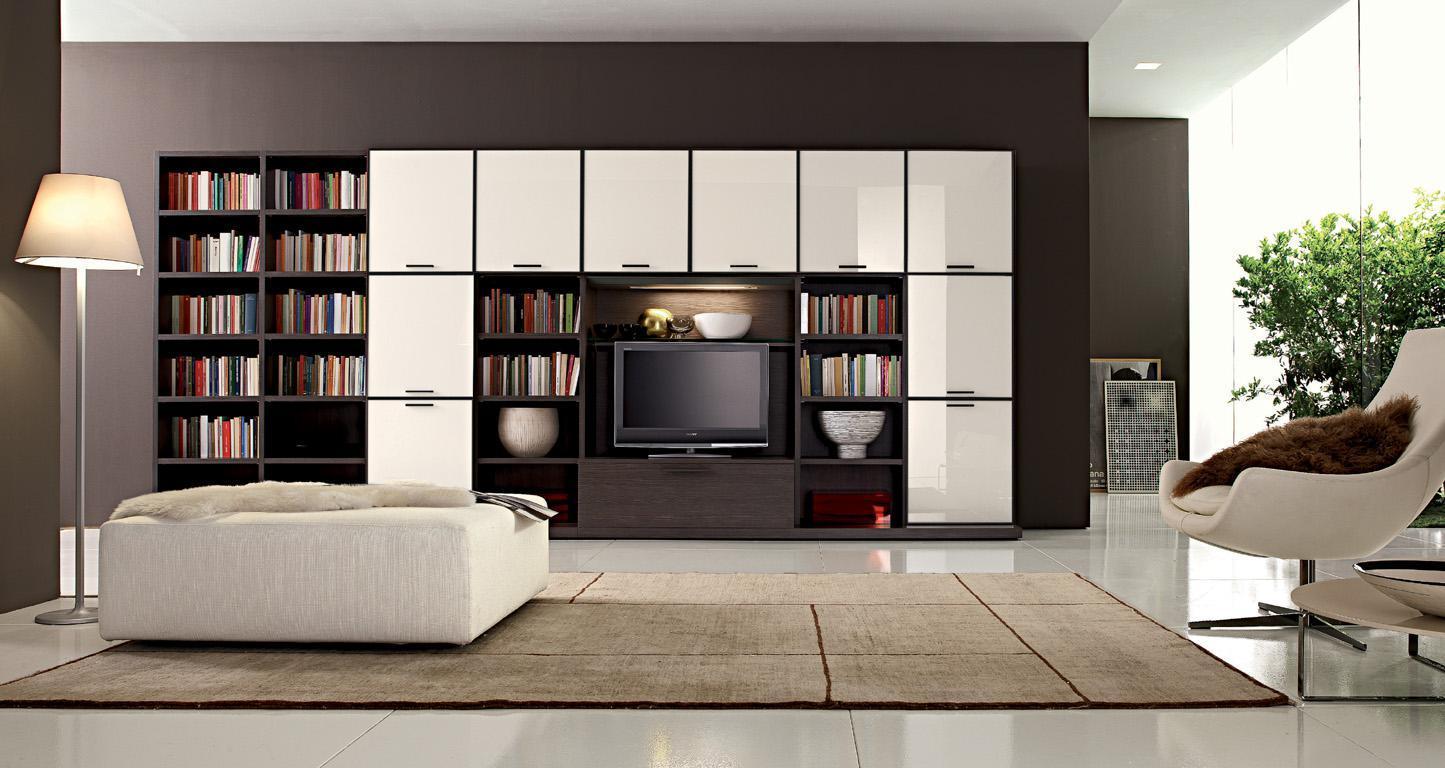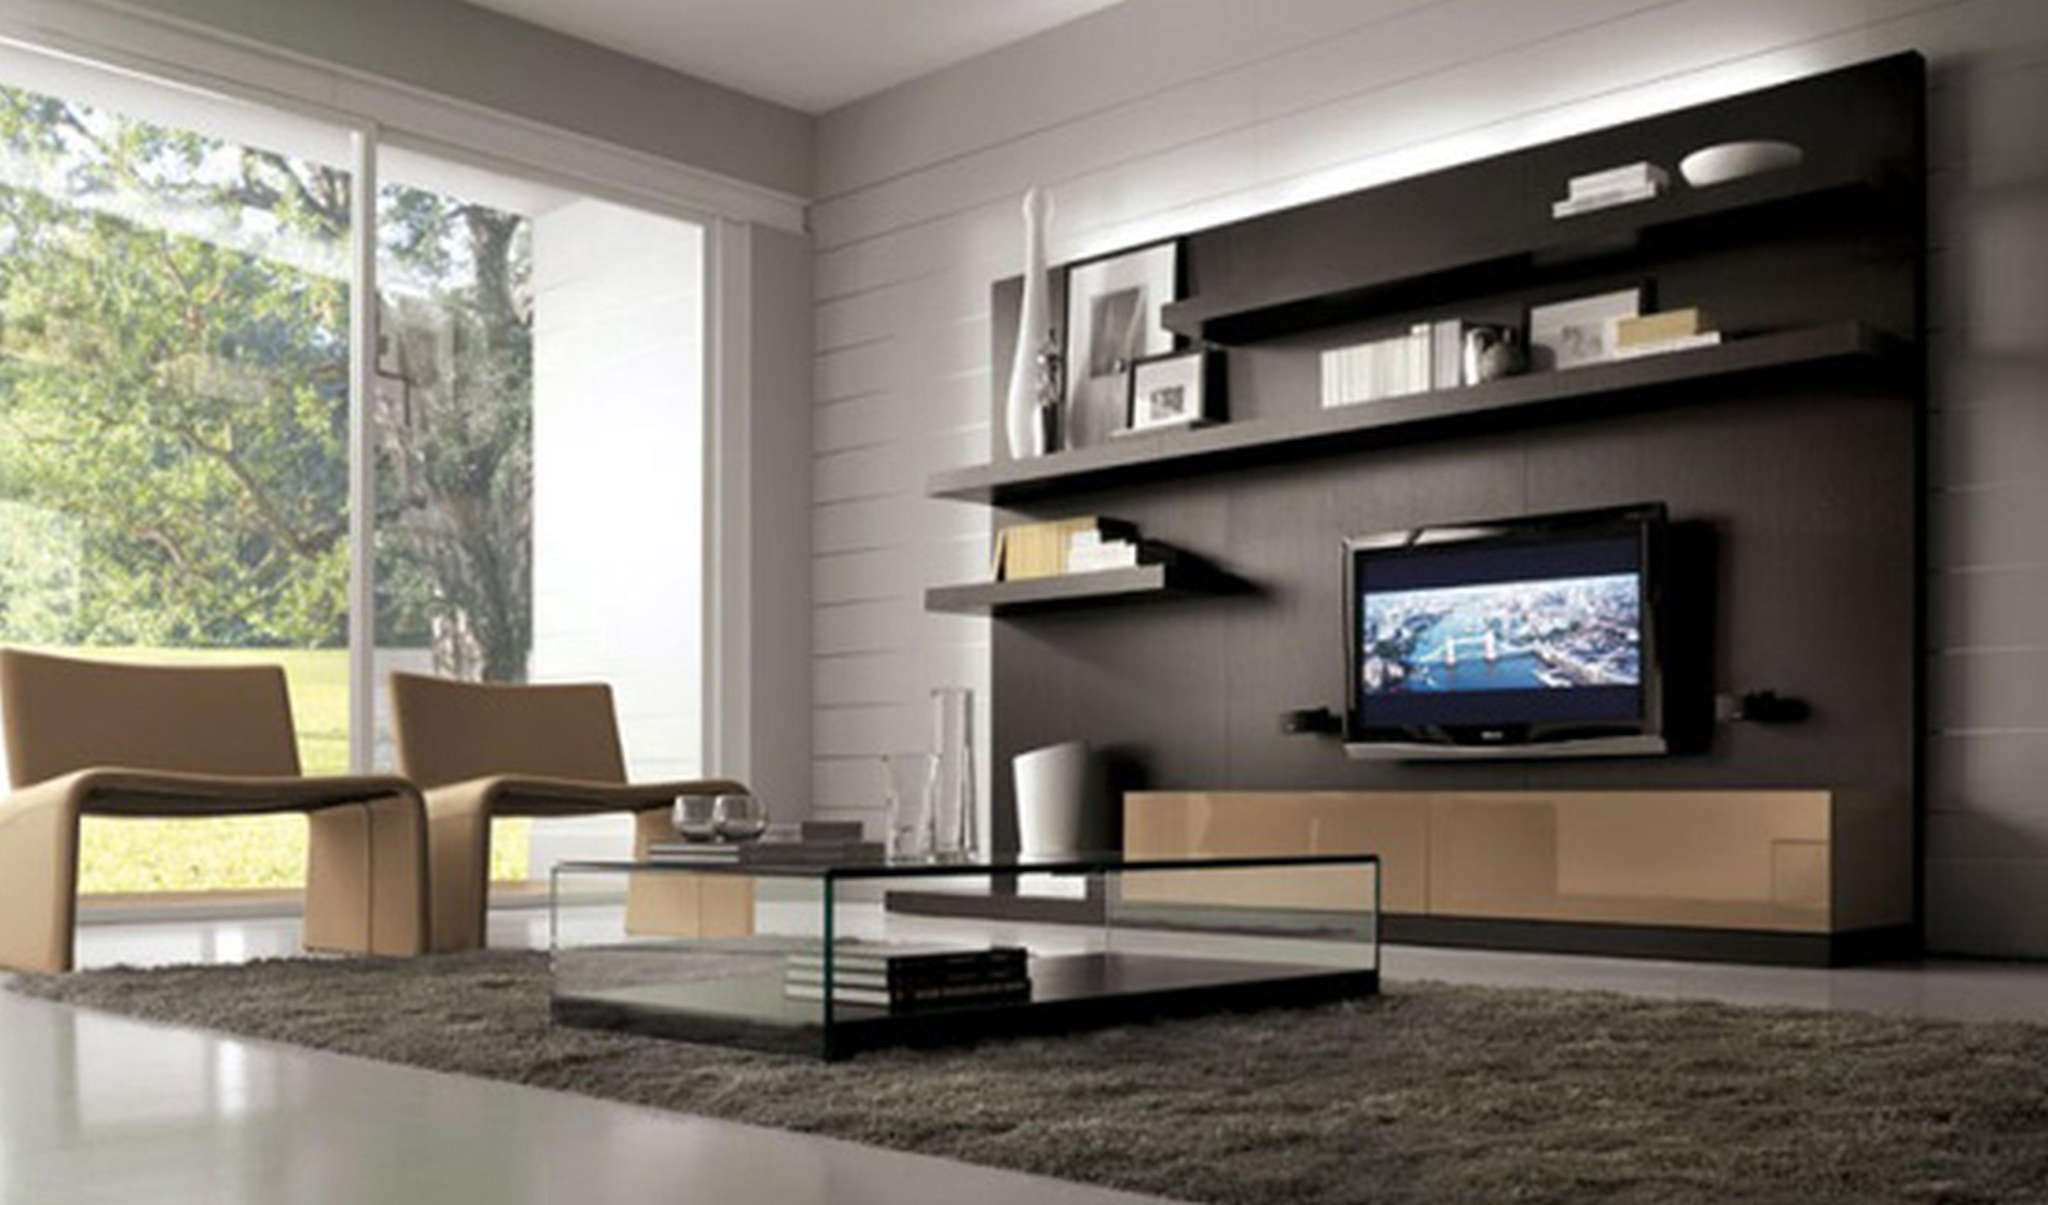The first image is the image on the left, the second image is the image on the right. Given the left and right images, does the statement "The lamp in the image on the left is sitting on a table." hold true? Answer yes or no. No. 